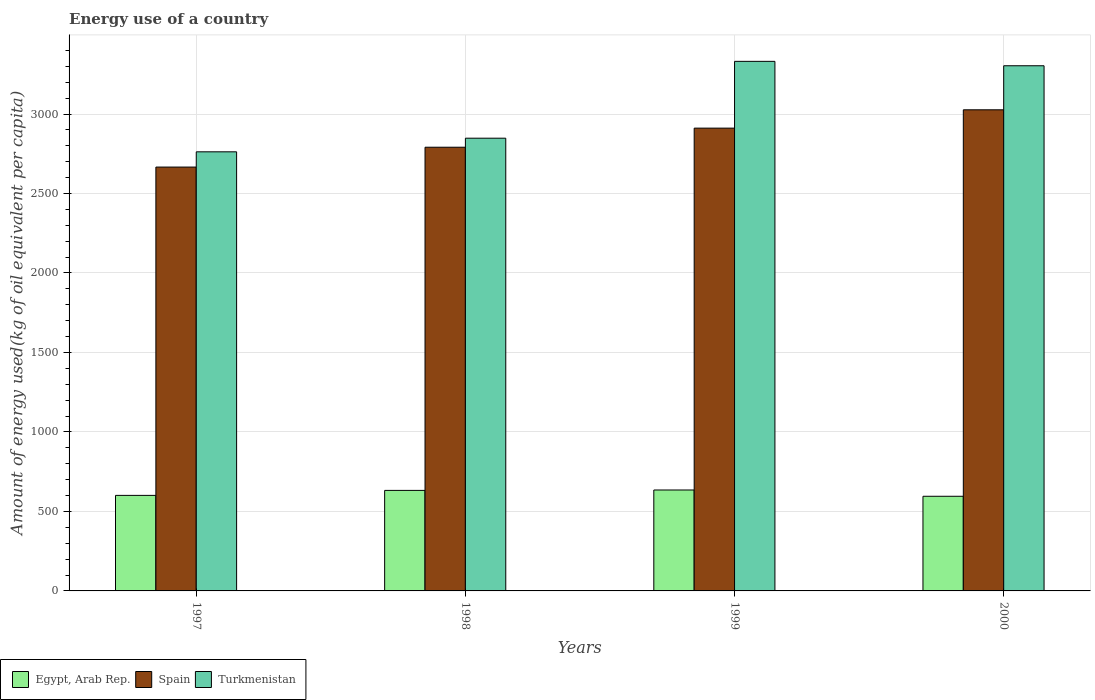How many different coloured bars are there?
Offer a terse response. 3. How many bars are there on the 2nd tick from the left?
Your answer should be very brief. 3. What is the label of the 3rd group of bars from the left?
Keep it short and to the point. 1999. What is the amount of energy used in in Egypt, Arab Rep. in 1997?
Give a very brief answer. 601. Across all years, what is the maximum amount of energy used in in Egypt, Arab Rep.?
Your answer should be compact. 634.94. Across all years, what is the minimum amount of energy used in in Spain?
Ensure brevity in your answer.  2666.26. What is the total amount of energy used in in Turkmenistan in the graph?
Provide a succinct answer. 1.22e+04. What is the difference between the amount of energy used in in Spain in 1998 and that in 1999?
Your answer should be very brief. -120.1. What is the difference between the amount of energy used in in Spain in 2000 and the amount of energy used in in Egypt, Arab Rep. in 1997?
Keep it short and to the point. 2425.49. What is the average amount of energy used in in Egypt, Arab Rep. per year?
Offer a terse response. 615.92. In the year 2000, what is the difference between the amount of energy used in in Egypt, Arab Rep. and amount of energy used in in Spain?
Your answer should be compact. -2431.13. What is the ratio of the amount of energy used in in Egypt, Arab Rep. in 1997 to that in 2000?
Provide a short and direct response. 1.01. What is the difference between the highest and the second highest amount of energy used in in Spain?
Provide a short and direct response. 115.31. What is the difference between the highest and the lowest amount of energy used in in Spain?
Offer a very short reply. 360.23. What does the 3rd bar from the left in 1997 represents?
Offer a terse response. Turkmenistan. What does the 1st bar from the right in 1999 represents?
Keep it short and to the point. Turkmenistan. How many bars are there?
Provide a succinct answer. 12. Are all the bars in the graph horizontal?
Provide a succinct answer. No. How many years are there in the graph?
Keep it short and to the point. 4. What is the difference between two consecutive major ticks on the Y-axis?
Your answer should be compact. 500. Where does the legend appear in the graph?
Your response must be concise. Bottom left. What is the title of the graph?
Offer a terse response. Energy use of a country. What is the label or title of the Y-axis?
Your answer should be very brief. Amount of energy used(kg of oil equivalent per capita). What is the Amount of energy used(kg of oil equivalent per capita) of Egypt, Arab Rep. in 1997?
Keep it short and to the point. 601. What is the Amount of energy used(kg of oil equivalent per capita) in Spain in 1997?
Give a very brief answer. 2666.26. What is the Amount of energy used(kg of oil equivalent per capita) of Turkmenistan in 1997?
Your response must be concise. 2762.15. What is the Amount of energy used(kg of oil equivalent per capita) in Egypt, Arab Rep. in 1998?
Your answer should be compact. 632.39. What is the Amount of energy used(kg of oil equivalent per capita) of Spain in 1998?
Offer a very short reply. 2791.08. What is the Amount of energy used(kg of oil equivalent per capita) of Turkmenistan in 1998?
Provide a succinct answer. 2847.9. What is the Amount of energy used(kg of oil equivalent per capita) in Egypt, Arab Rep. in 1999?
Make the answer very short. 634.94. What is the Amount of energy used(kg of oil equivalent per capita) in Spain in 1999?
Offer a terse response. 2911.18. What is the Amount of energy used(kg of oil equivalent per capita) in Turkmenistan in 1999?
Your response must be concise. 3331.28. What is the Amount of energy used(kg of oil equivalent per capita) of Egypt, Arab Rep. in 2000?
Ensure brevity in your answer.  595.36. What is the Amount of energy used(kg of oil equivalent per capita) in Spain in 2000?
Make the answer very short. 3026.49. What is the Amount of energy used(kg of oil equivalent per capita) in Turkmenistan in 2000?
Provide a short and direct response. 3303.61. Across all years, what is the maximum Amount of energy used(kg of oil equivalent per capita) of Egypt, Arab Rep.?
Provide a succinct answer. 634.94. Across all years, what is the maximum Amount of energy used(kg of oil equivalent per capita) of Spain?
Provide a succinct answer. 3026.49. Across all years, what is the maximum Amount of energy used(kg of oil equivalent per capita) in Turkmenistan?
Your answer should be very brief. 3331.28. Across all years, what is the minimum Amount of energy used(kg of oil equivalent per capita) in Egypt, Arab Rep.?
Offer a very short reply. 595.36. Across all years, what is the minimum Amount of energy used(kg of oil equivalent per capita) in Spain?
Provide a succinct answer. 2666.26. Across all years, what is the minimum Amount of energy used(kg of oil equivalent per capita) in Turkmenistan?
Offer a very short reply. 2762.15. What is the total Amount of energy used(kg of oil equivalent per capita) of Egypt, Arab Rep. in the graph?
Keep it short and to the point. 2463.68. What is the total Amount of energy used(kg of oil equivalent per capita) of Spain in the graph?
Offer a very short reply. 1.14e+04. What is the total Amount of energy used(kg of oil equivalent per capita) of Turkmenistan in the graph?
Make the answer very short. 1.22e+04. What is the difference between the Amount of energy used(kg of oil equivalent per capita) of Egypt, Arab Rep. in 1997 and that in 1998?
Provide a succinct answer. -31.38. What is the difference between the Amount of energy used(kg of oil equivalent per capita) of Spain in 1997 and that in 1998?
Give a very brief answer. -124.82. What is the difference between the Amount of energy used(kg of oil equivalent per capita) of Turkmenistan in 1997 and that in 1998?
Provide a short and direct response. -85.75. What is the difference between the Amount of energy used(kg of oil equivalent per capita) in Egypt, Arab Rep. in 1997 and that in 1999?
Your response must be concise. -33.94. What is the difference between the Amount of energy used(kg of oil equivalent per capita) of Spain in 1997 and that in 1999?
Keep it short and to the point. -244.92. What is the difference between the Amount of energy used(kg of oil equivalent per capita) in Turkmenistan in 1997 and that in 1999?
Your answer should be very brief. -569.13. What is the difference between the Amount of energy used(kg of oil equivalent per capita) of Egypt, Arab Rep. in 1997 and that in 2000?
Provide a succinct answer. 5.64. What is the difference between the Amount of energy used(kg of oil equivalent per capita) in Spain in 1997 and that in 2000?
Offer a very short reply. -360.23. What is the difference between the Amount of energy used(kg of oil equivalent per capita) of Turkmenistan in 1997 and that in 2000?
Offer a terse response. -541.46. What is the difference between the Amount of energy used(kg of oil equivalent per capita) in Egypt, Arab Rep. in 1998 and that in 1999?
Offer a very short reply. -2.56. What is the difference between the Amount of energy used(kg of oil equivalent per capita) in Spain in 1998 and that in 1999?
Provide a short and direct response. -120.1. What is the difference between the Amount of energy used(kg of oil equivalent per capita) of Turkmenistan in 1998 and that in 1999?
Offer a very short reply. -483.38. What is the difference between the Amount of energy used(kg of oil equivalent per capita) in Egypt, Arab Rep. in 1998 and that in 2000?
Give a very brief answer. 37.03. What is the difference between the Amount of energy used(kg of oil equivalent per capita) of Spain in 1998 and that in 2000?
Offer a terse response. -235.41. What is the difference between the Amount of energy used(kg of oil equivalent per capita) of Turkmenistan in 1998 and that in 2000?
Your answer should be very brief. -455.71. What is the difference between the Amount of energy used(kg of oil equivalent per capita) of Egypt, Arab Rep. in 1999 and that in 2000?
Make the answer very short. 39.58. What is the difference between the Amount of energy used(kg of oil equivalent per capita) in Spain in 1999 and that in 2000?
Ensure brevity in your answer.  -115.31. What is the difference between the Amount of energy used(kg of oil equivalent per capita) in Turkmenistan in 1999 and that in 2000?
Ensure brevity in your answer.  27.67. What is the difference between the Amount of energy used(kg of oil equivalent per capita) in Egypt, Arab Rep. in 1997 and the Amount of energy used(kg of oil equivalent per capita) in Spain in 1998?
Offer a terse response. -2190.08. What is the difference between the Amount of energy used(kg of oil equivalent per capita) in Egypt, Arab Rep. in 1997 and the Amount of energy used(kg of oil equivalent per capita) in Turkmenistan in 1998?
Provide a short and direct response. -2246.9. What is the difference between the Amount of energy used(kg of oil equivalent per capita) in Spain in 1997 and the Amount of energy used(kg of oil equivalent per capita) in Turkmenistan in 1998?
Make the answer very short. -181.63. What is the difference between the Amount of energy used(kg of oil equivalent per capita) of Egypt, Arab Rep. in 1997 and the Amount of energy used(kg of oil equivalent per capita) of Spain in 1999?
Make the answer very short. -2310.18. What is the difference between the Amount of energy used(kg of oil equivalent per capita) in Egypt, Arab Rep. in 1997 and the Amount of energy used(kg of oil equivalent per capita) in Turkmenistan in 1999?
Your response must be concise. -2730.28. What is the difference between the Amount of energy used(kg of oil equivalent per capita) of Spain in 1997 and the Amount of energy used(kg of oil equivalent per capita) of Turkmenistan in 1999?
Your answer should be compact. -665.02. What is the difference between the Amount of energy used(kg of oil equivalent per capita) in Egypt, Arab Rep. in 1997 and the Amount of energy used(kg of oil equivalent per capita) in Spain in 2000?
Provide a succinct answer. -2425.49. What is the difference between the Amount of energy used(kg of oil equivalent per capita) in Egypt, Arab Rep. in 1997 and the Amount of energy used(kg of oil equivalent per capita) in Turkmenistan in 2000?
Make the answer very short. -2702.61. What is the difference between the Amount of energy used(kg of oil equivalent per capita) of Spain in 1997 and the Amount of energy used(kg of oil equivalent per capita) of Turkmenistan in 2000?
Keep it short and to the point. -637.34. What is the difference between the Amount of energy used(kg of oil equivalent per capita) of Egypt, Arab Rep. in 1998 and the Amount of energy used(kg of oil equivalent per capita) of Spain in 1999?
Offer a very short reply. -2278.8. What is the difference between the Amount of energy used(kg of oil equivalent per capita) in Egypt, Arab Rep. in 1998 and the Amount of energy used(kg of oil equivalent per capita) in Turkmenistan in 1999?
Keep it short and to the point. -2698.89. What is the difference between the Amount of energy used(kg of oil equivalent per capita) in Spain in 1998 and the Amount of energy used(kg of oil equivalent per capita) in Turkmenistan in 1999?
Offer a very short reply. -540.2. What is the difference between the Amount of energy used(kg of oil equivalent per capita) in Egypt, Arab Rep. in 1998 and the Amount of energy used(kg of oil equivalent per capita) in Spain in 2000?
Give a very brief answer. -2394.1. What is the difference between the Amount of energy used(kg of oil equivalent per capita) in Egypt, Arab Rep. in 1998 and the Amount of energy used(kg of oil equivalent per capita) in Turkmenistan in 2000?
Your answer should be compact. -2671.22. What is the difference between the Amount of energy used(kg of oil equivalent per capita) of Spain in 1998 and the Amount of energy used(kg of oil equivalent per capita) of Turkmenistan in 2000?
Make the answer very short. -512.53. What is the difference between the Amount of energy used(kg of oil equivalent per capita) in Egypt, Arab Rep. in 1999 and the Amount of energy used(kg of oil equivalent per capita) in Spain in 2000?
Offer a very short reply. -2391.55. What is the difference between the Amount of energy used(kg of oil equivalent per capita) in Egypt, Arab Rep. in 1999 and the Amount of energy used(kg of oil equivalent per capita) in Turkmenistan in 2000?
Provide a short and direct response. -2668.67. What is the difference between the Amount of energy used(kg of oil equivalent per capita) in Spain in 1999 and the Amount of energy used(kg of oil equivalent per capita) in Turkmenistan in 2000?
Give a very brief answer. -392.42. What is the average Amount of energy used(kg of oil equivalent per capita) of Egypt, Arab Rep. per year?
Make the answer very short. 615.92. What is the average Amount of energy used(kg of oil equivalent per capita) of Spain per year?
Your response must be concise. 2848.75. What is the average Amount of energy used(kg of oil equivalent per capita) in Turkmenistan per year?
Provide a short and direct response. 3061.23. In the year 1997, what is the difference between the Amount of energy used(kg of oil equivalent per capita) in Egypt, Arab Rep. and Amount of energy used(kg of oil equivalent per capita) in Spain?
Ensure brevity in your answer.  -2065.26. In the year 1997, what is the difference between the Amount of energy used(kg of oil equivalent per capita) of Egypt, Arab Rep. and Amount of energy used(kg of oil equivalent per capita) of Turkmenistan?
Provide a short and direct response. -2161.15. In the year 1997, what is the difference between the Amount of energy used(kg of oil equivalent per capita) of Spain and Amount of energy used(kg of oil equivalent per capita) of Turkmenistan?
Give a very brief answer. -95.88. In the year 1998, what is the difference between the Amount of energy used(kg of oil equivalent per capita) of Egypt, Arab Rep. and Amount of energy used(kg of oil equivalent per capita) of Spain?
Your answer should be very brief. -2158.69. In the year 1998, what is the difference between the Amount of energy used(kg of oil equivalent per capita) of Egypt, Arab Rep. and Amount of energy used(kg of oil equivalent per capita) of Turkmenistan?
Offer a terse response. -2215.51. In the year 1998, what is the difference between the Amount of energy used(kg of oil equivalent per capita) of Spain and Amount of energy used(kg of oil equivalent per capita) of Turkmenistan?
Your answer should be very brief. -56.82. In the year 1999, what is the difference between the Amount of energy used(kg of oil equivalent per capita) of Egypt, Arab Rep. and Amount of energy used(kg of oil equivalent per capita) of Spain?
Ensure brevity in your answer.  -2276.24. In the year 1999, what is the difference between the Amount of energy used(kg of oil equivalent per capita) in Egypt, Arab Rep. and Amount of energy used(kg of oil equivalent per capita) in Turkmenistan?
Give a very brief answer. -2696.34. In the year 1999, what is the difference between the Amount of energy used(kg of oil equivalent per capita) in Spain and Amount of energy used(kg of oil equivalent per capita) in Turkmenistan?
Your answer should be compact. -420.1. In the year 2000, what is the difference between the Amount of energy used(kg of oil equivalent per capita) in Egypt, Arab Rep. and Amount of energy used(kg of oil equivalent per capita) in Spain?
Provide a short and direct response. -2431.13. In the year 2000, what is the difference between the Amount of energy used(kg of oil equivalent per capita) in Egypt, Arab Rep. and Amount of energy used(kg of oil equivalent per capita) in Turkmenistan?
Give a very brief answer. -2708.25. In the year 2000, what is the difference between the Amount of energy used(kg of oil equivalent per capita) in Spain and Amount of energy used(kg of oil equivalent per capita) in Turkmenistan?
Your response must be concise. -277.12. What is the ratio of the Amount of energy used(kg of oil equivalent per capita) of Egypt, Arab Rep. in 1997 to that in 1998?
Ensure brevity in your answer.  0.95. What is the ratio of the Amount of energy used(kg of oil equivalent per capita) of Spain in 1997 to that in 1998?
Offer a terse response. 0.96. What is the ratio of the Amount of energy used(kg of oil equivalent per capita) in Turkmenistan in 1997 to that in 1998?
Your answer should be very brief. 0.97. What is the ratio of the Amount of energy used(kg of oil equivalent per capita) in Egypt, Arab Rep. in 1997 to that in 1999?
Give a very brief answer. 0.95. What is the ratio of the Amount of energy used(kg of oil equivalent per capita) of Spain in 1997 to that in 1999?
Ensure brevity in your answer.  0.92. What is the ratio of the Amount of energy used(kg of oil equivalent per capita) in Turkmenistan in 1997 to that in 1999?
Make the answer very short. 0.83. What is the ratio of the Amount of energy used(kg of oil equivalent per capita) in Egypt, Arab Rep. in 1997 to that in 2000?
Make the answer very short. 1.01. What is the ratio of the Amount of energy used(kg of oil equivalent per capita) of Spain in 1997 to that in 2000?
Your answer should be compact. 0.88. What is the ratio of the Amount of energy used(kg of oil equivalent per capita) of Turkmenistan in 1997 to that in 2000?
Keep it short and to the point. 0.84. What is the ratio of the Amount of energy used(kg of oil equivalent per capita) of Egypt, Arab Rep. in 1998 to that in 1999?
Give a very brief answer. 1. What is the ratio of the Amount of energy used(kg of oil equivalent per capita) of Spain in 1998 to that in 1999?
Your response must be concise. 0.96. What is the ratio of the Amount of energy used(kg of oil equivalent per capita) in Turkmenistan in 1998 to that in 1999?
Make the answer very short. 0.85. What is the ratio of the Amount of energy used(kg of oil equivalent per capita) of Egypt, Arab Rep. in 1998 to that in 2000?
Give a very brief answer. 1.06. What is the ratio of the Amount of energy used(kg of oil equivalent per capita) of Spain in 1998 to that in 2000?
Your answer should be very brief. 0.92. What is the ratio of the Amount of energy used(kg of oil equivalent per capita) in Turkmenistan in 1998 to that in 2000?
Provide a short and direct response. 0.86. What is the ratio of the Amount of energy used(kg of oil equivalent per capita) of Egypt, Arab Rep. in 1999 to that in 2000?
Your answer should be very brief. 1.07. What is the ratio of the Amount of energy used(kg of oil equivalent per capita) in Spain in 1999 to that in 2000?
Provide a succinct answer. 0.96. What is the ratio of the Amount of energy used(kg of oil equivalent per capita) in Turkmenistan in 1999 to that in 2000?
Make the answer very short. 1.01. What is the difference between the highest and the second highest Amount of energy used(kg of oil equivalent per capita) of Egypt, Arab Rep.?
Provide a short and direct response. 2.56. What is the difference between the highest and the second highest Amount of energy used(kg of oil equivalent per capita) in Spain?
Offer a very short reply. 115.31. What is the difference between the highest and the second highest Amount of energy used(kg of oil equivalent per capita) of Turkmenistan?
Offer a very short reply. 27.67. What is the difference between the highest and the lowest Amount of energy used(kg of oil equivalent per capita) of Egypt, Arab Rep.?
Make the answer very short. 39.58. What is the difference between the highest and the lowest Amount of energy used(kg of oil equivalent per capita) of Spain?
Offer a terse response. 360.23. What is the difference between the highest and the lowest Amount of energy used(kg of oil equivalent per capita) in Turkmenistan?
Make the answer very short. 569.13. 